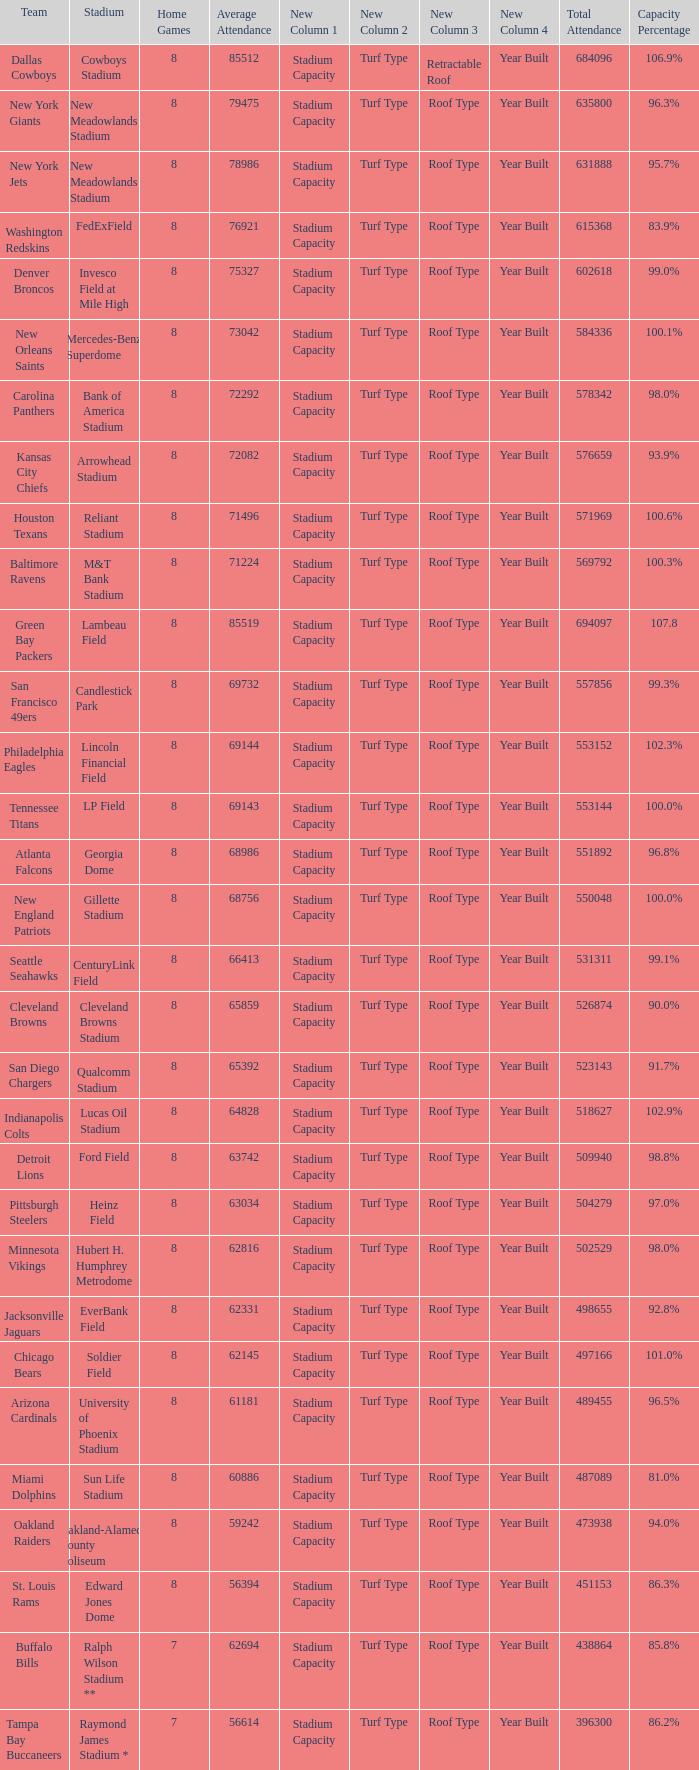What is the name of the stadium when the capacity percentage is 83.9% FedExField. 